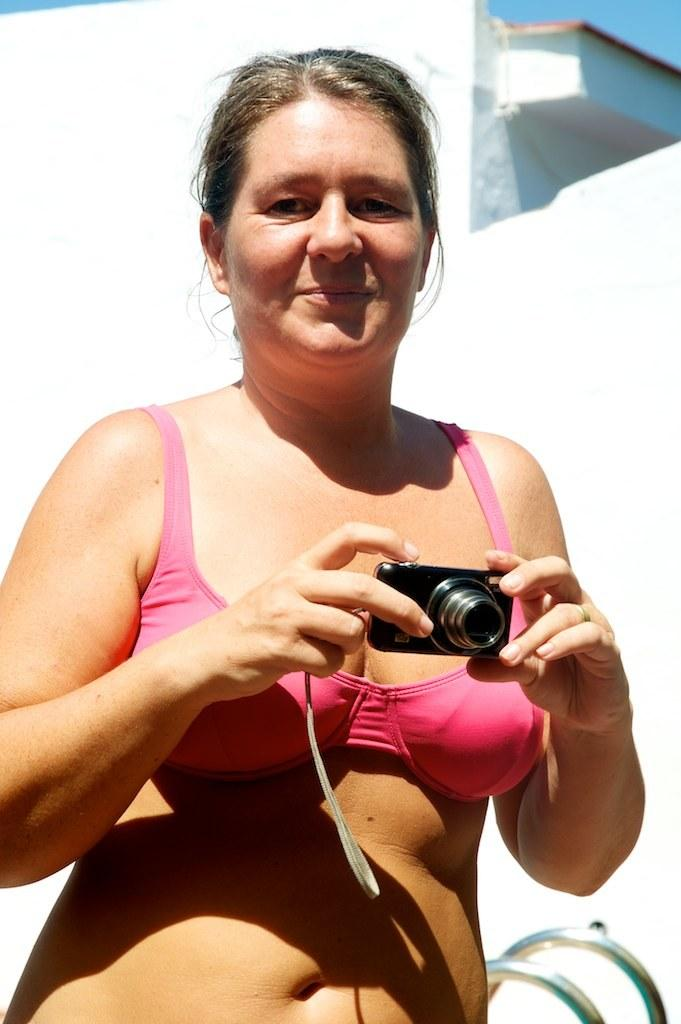Who is the main subject in the image? There is a lady in the image. What is the lady holding in the image? The lady is holding a camera with both hands. What type of clothing is the lady wearing? The lady is wearing a swimsuit. What can be seen in the background of the image? There is a white building in the background of the image. What type of cake is the lady holding in the image? There is no cake present in the image; the lady is holding a camera. Can you see any bubbles around the lady in the image? There are no bubbles visible in the image. 